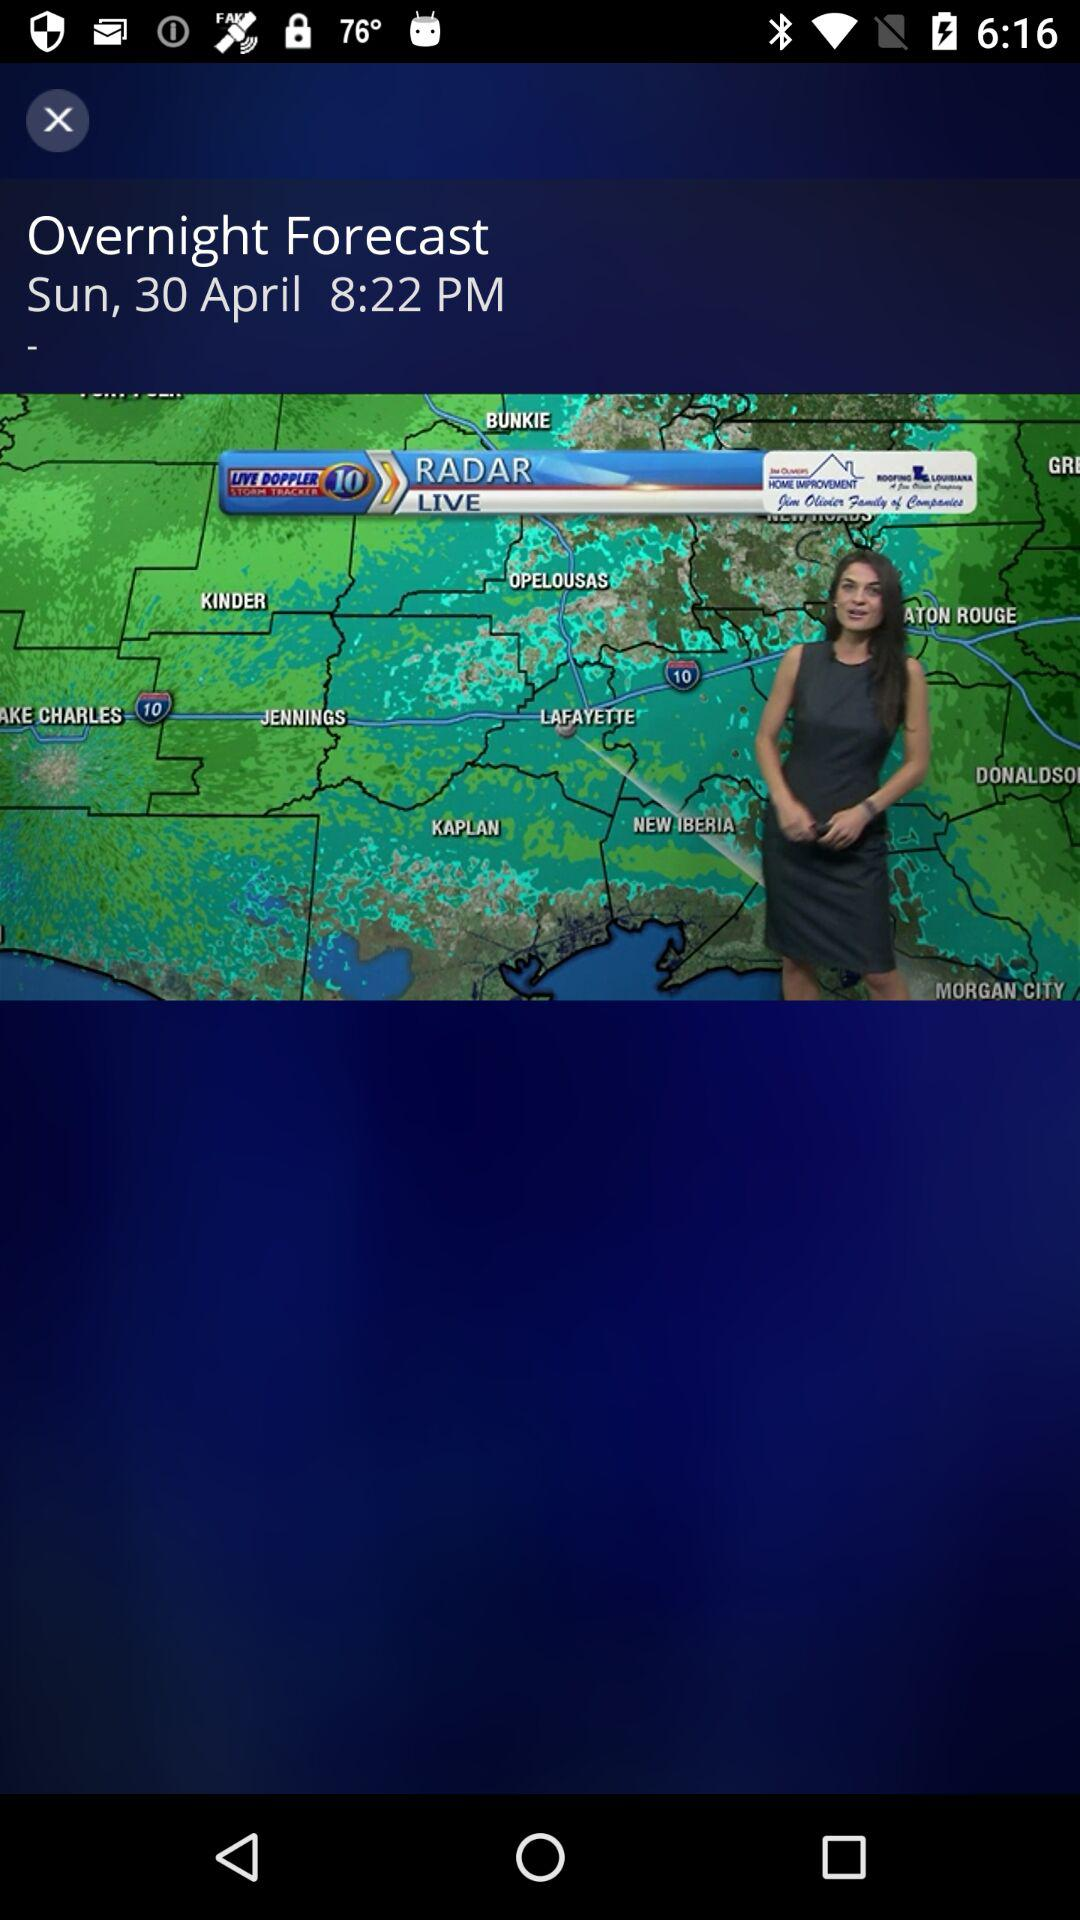What was the time of the overnight forecast? The time was 8:22 p.m. 